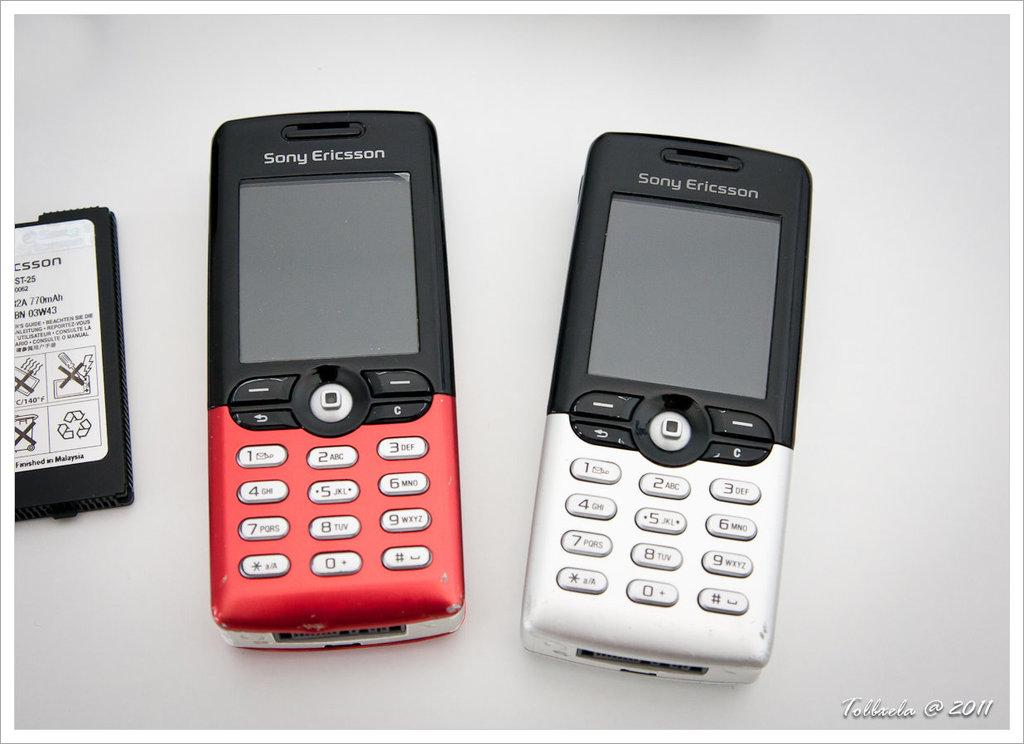<image>
Describe the image concisely. Two Sony Ericson branded cellphones are sitting side by side on a gray surface. 